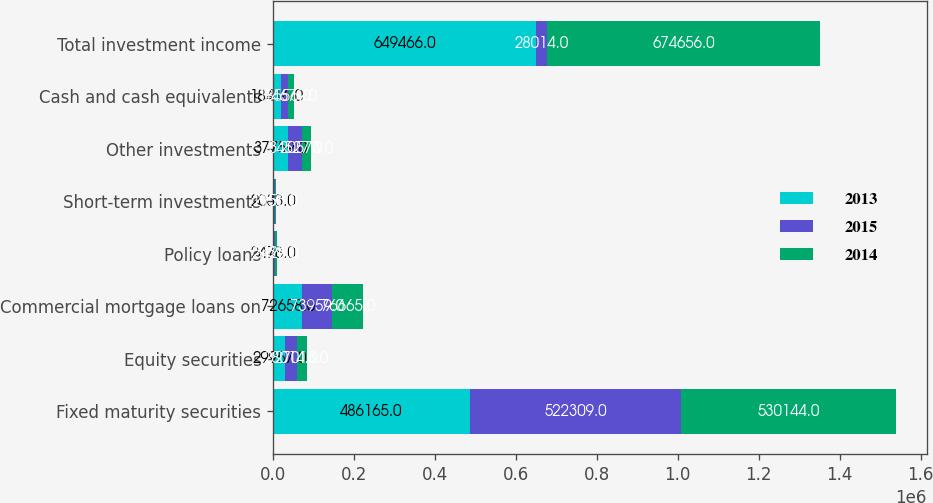Convert chart to OTSL. <chart><loc_0><loc_0><loc_500><loc_500><stacked_bar_chart><ecel><fcel>Fixed maturity securities<fcel>Equity securities<fcel>Commercial mortgage loans on<fcel>Policy loans<fcel>Short-term investments<fcel>Other investments<fcel>Cash and cash equivalents<fcel>Total investment income<nl><fcel>2013<fcel>486165<fcel>29957<fcel>72658<fcel>2478<fcel>2033<fcel>37759<fcel>18416<fcel>649466<nl><fcel>2015<fcel>522309<fcel>28014<fcel>73959<fcel>2939<fcel>1950<fcel>34527<fcel>18556<fcel>28014<nl><fcel>2014<fcel>530144<fcel>27013<fcel>76665<fcel>3426<fcel>2156<fcel>20573<fcel>14679<fcel>674656<nl></chart> 